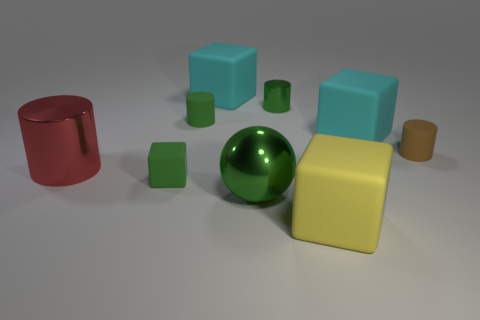Subtract all big cylinders. How many cylinders are left? 3 Add 1 small yellow things. How many objects exist? 10 Subtract all blue cubes. How many green cylinders are left? 2 Subtract 1 balls. How many balls are left? 0 Subtract all blocks. How many objects are left? 5 Subtract all cyan cubes. How many cubes are left? 2 Add 7 large cyan cubes. How many large cyan cubes are left? 9 Add 4 matte cubes. How many matte cubes exist? 8 Subtract 0 purple cylinders. How many objects are left? 9 Subtract all green cylinders. Subtract all yellow balls. How many cylinders are left? 2 